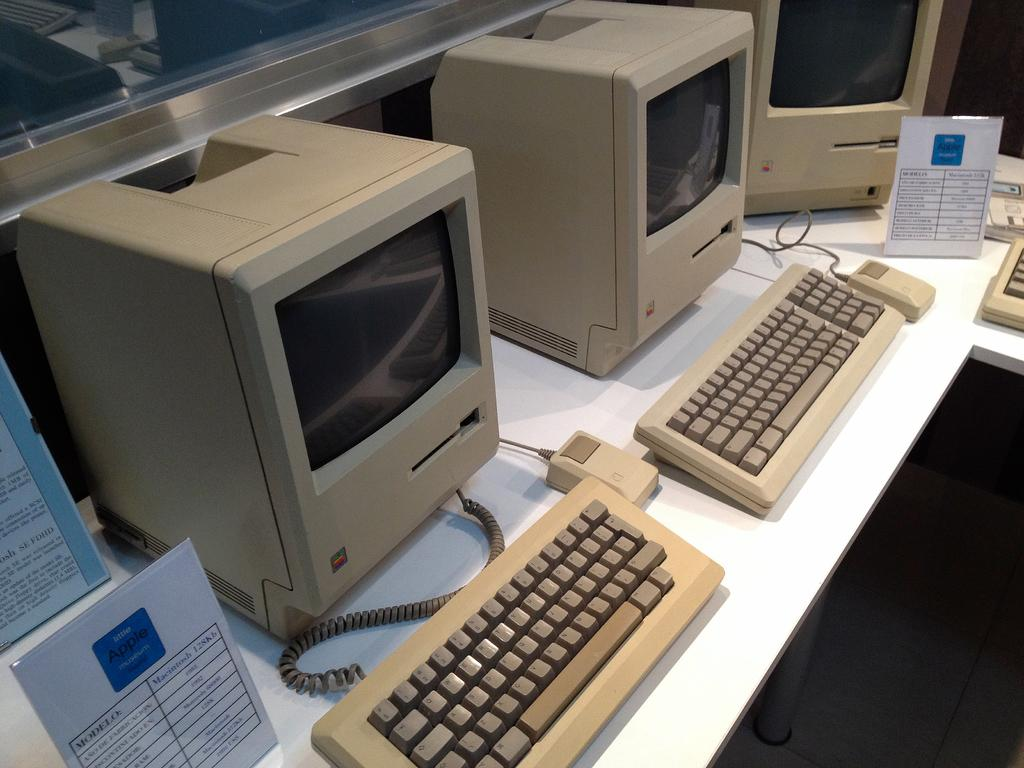<image>
Create a compact narrative representing the image presented. Two old computers sit on a desk in the little Apple Museum. 